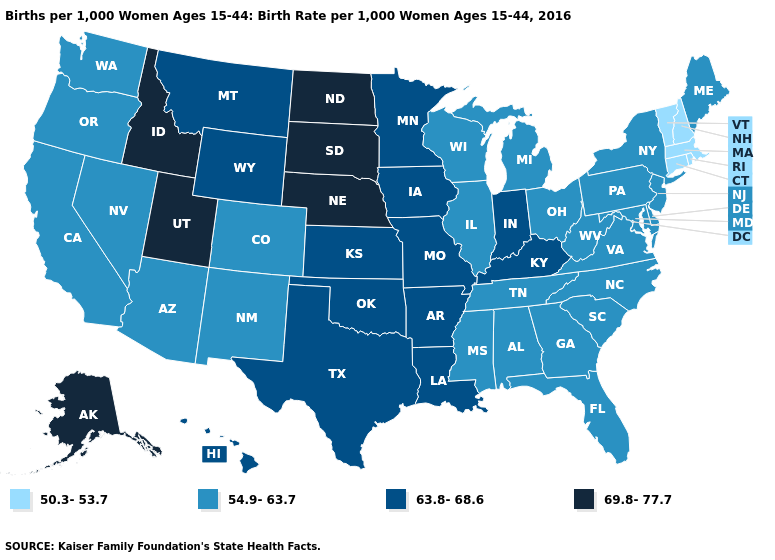Name the states that have a value in the range 69.8-77.7?
Quick response, please. Alaska, Idaho, Nebraska, North Dakota, South Dakota, Utah. What is the value of West Virginia?
Be succinct. 54.9-63.7. What is the value of New Jersey?
Short answer required. 54.9-63.7. Name the states that have a value in the range 50.3-53.7?
Short answer required. Connecticut, Massachusetts, New Hampshire, Rhode Island, Vermont. Does Tennessee have the same value as Arkansas?
Write a very short answer. No. Does Idaho have the lowest value in the West?
Give a very brief answer. No. Name the states that have a value in the range 50.3-53.7?
Be succinct. Connecticut, Massachusetts, New Hampshire, Rhode Island, Vermont. Name the states that have a value in the range 50.3-53.7?
Be succinct. Connecticut, Massachusetts, New Hampshire, Rhode Island, Vermont. What is the lowest value in the MidWest?
Be succinct. 54.9-63.7. What is the value of Connecticut?
Be succinct. 50.3-53.7. Does Maine have a higher value than Massachusetts?
Short answer required. Yes. Does Nevada have the lowest value in the West?
Short answer required. Yes. Name the states that have a value in the range 54.9-63.7?
Quick response, please. Alabama, Arizona, California, Colorado, Delaware, Florida, Georgia, Illinois, Maine, Maryland, Michigan, Mississippi, Nevada, New Jersey, New Mexico, New York, North Carolina, Ohio, Oregon, Pennsylvania, South Carolina, Tennessee, Virginia, Washington, West Virginia, Wisconsin. What is the lowest value in the Northeast?
Concise answer only. 50.3-53.7. 